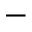Convert formula to latex. <formula><loc_0><loc_0><loc_500><loc_500>-</formula> 